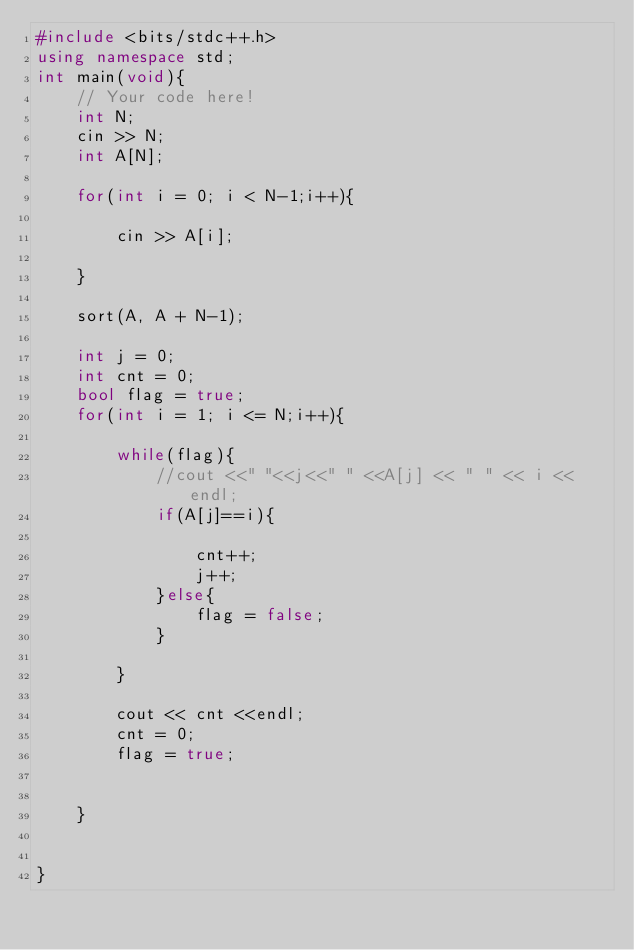<code> <loc_0><loc_0><loc_500><loc_500><_C++_>#include <bits/stdc++.h>
using namespace std;
int main(void){
    // Your code here!
    int N;
    cin >> N;
    int A[N];

    for(int i = 0; i < N-1;i++){
        
        cin >> A[i];
        
    }
    
    sort(A, A + N-1);
    
    int j = 0;
    int cnt = 0;
    bool flag = true;
    for(int i = 1; i <= N;i++){
        
        while(flag){
            //cout <<" "<<j<<" " <<A[j] << " " << i << endl;
            if(A[j]==i){
                
                cnt++;
                j++;
            }else{
                flag = false;
            }
        
        }
        
        cout << cnt <<endl;
        cnt = 0;
        flag = true;
        
        
    }
    
    
}
</code> 